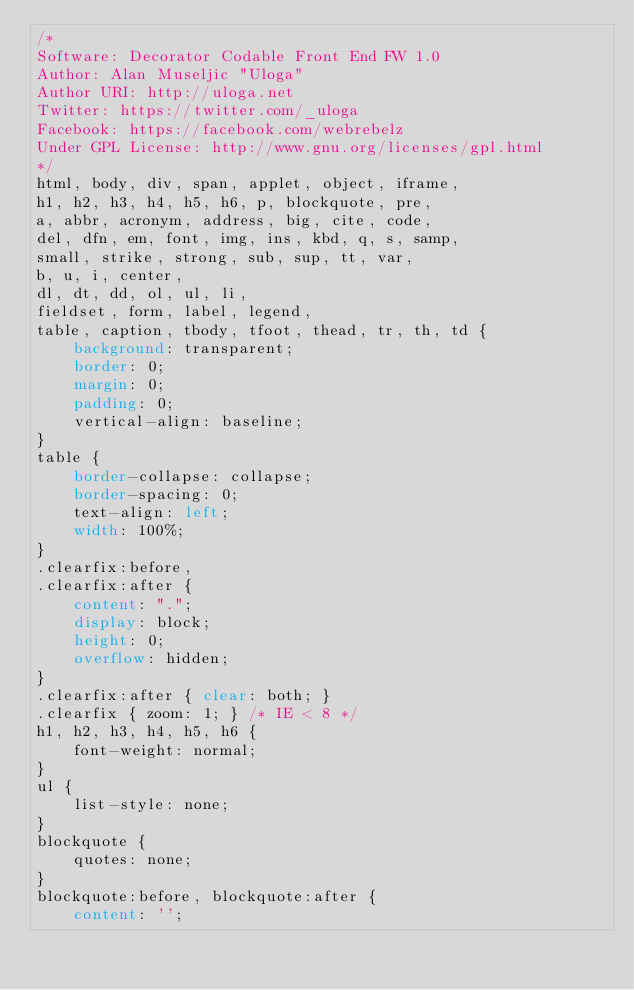Convert code to text. <code><loc_0><loc_0><loc_500><loc_500><_CSS_>/*
Software: Decorator Codable Front End FW 1.0
Author: Alan Museljic "Uloga"
Author URI: http://uloga.net
Twitter: https://twitter.com/_uloga
Facebook: https://facebook.com/webrebelz
Under GPL License: http://www.gnu.org/licenses/gpl.html
*/
html, body, div, span, applet, object, iframe,
h1, h2, h3, h4, h5, h6, p, blockquote, pre,
a, abbr, acronym, address, big, cite, code,
del, dfn, em, font, img, ins, kbd, q, s, samp,
small, strike, strong, sub, sup, tt, var,
b, u, i, center,
dl, dt, dd, ol, ul, li,
fieldset, form, label, legend,
table, caption, tbody, tfoot, thead, tr, th, td {
    background: transparent;
    border: 0;
    margin: 0;
    padding: 0;
    vertical-align: baseline;
}
table {
    border-collapse: collapse;
    border-spacing: 0;
    text-align: left;
    width: 100%;
}
.clearfix:before,
.clearfix:after {
    content: ".";    
    display: block;    
    height: 0;    
    overflow: hidden; 
}
.clearfix:after { clear: both; }
.clearfix { zoom: 1; } /* IE < 8 */
h1, h2, h3, h4, h5, h6 {
    font-weight: normal;
}
ul {
    list-style: none;
}
blockquote {
    quotes: none;
}
blockquote:before, blockquote:after {
    content: '';</code> 